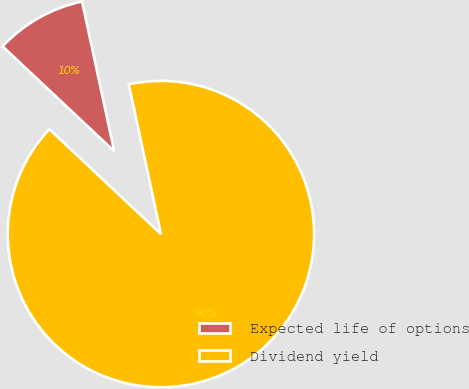Convert chart to OTSL. <chart><loc_0><loc_0><loc_500><loc_500><pie_chart><fcel>Expected life of options<fcel>Dividend yield<nl><fcel>9.63%<fcel>90.37%<nl></chart> 